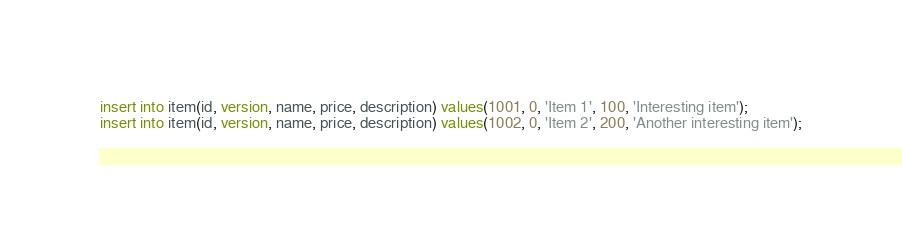Convert code to text. <code><loc_0><loc_0><loc_500><loc_500><_SQL_>insert into item(id, version, name, price, description) values(1001, 0, 'Item 1', 100, 'Interesting item');
insert into item(id, version, name, price, description) values(1002, 0, 'Item 2', 200, 'Another interesting item');</code> 